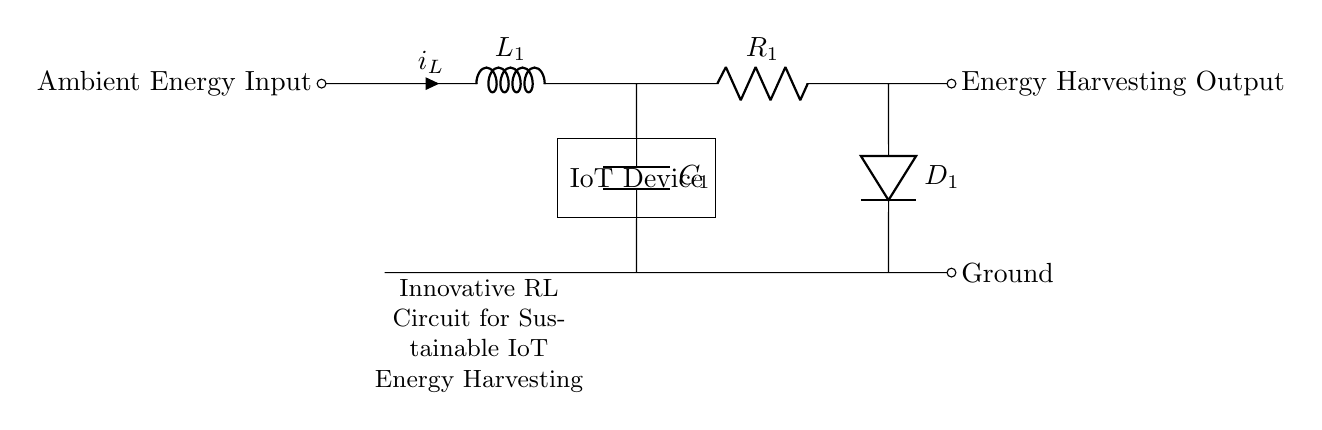What is the ambient energy input represented in the circuit? The ambient energy input is represented by the left node labeled "Ambient Energy Input," indicating the source of energy that will be harvested.
Answer: Ambient Energy Input What is the role of the inductor in this RL circuit? The inductor, labeled as L1, stores energy in a magnetic field when current flows through it, which is essential for energy harvesting as it helps to smooth out the current.
Answer: Energy storage What type of component is D1 in this circuit? D1 is a diode, which allows current to flow in one direction only, preventing backflow and ensuring that harvested energy is directed to the IoT device.
Answer: Diode What is the function of the capacitor C1 in this circuit? The capacitor C1 is used to store energy and smooth out voltage fluctuations, allowing for stable power supply to the IoT device.
Answer: Energy storage How are the inductor and resistor connected in this RL circuit? The inductor L1 and resistor R1 are connected in series, meaning that the same current flows through both components in the circuit.
Answer: Series connection What is the output from this energy harvesting circuit? The output from the circuit is indicated by the node labeled "Energy Harvesting Output," where the harvested energy is made available for use.
Answer: Energy Harvesting Output How does the configuration of this RL circuit contribute to sustainability? This RL circuit configuration promotes sustainability by enabling the efficient collection and utilization of ambient energy sources, reducing reliance on traditional power supplies.
Answer: Efficient energy harvesting 